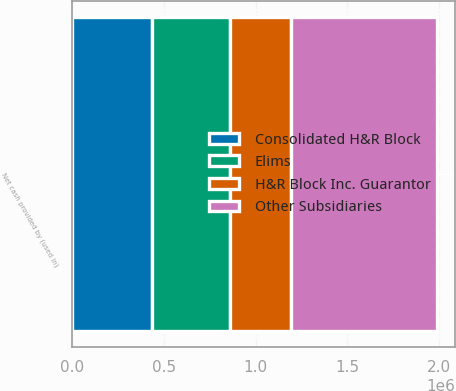Convert chart to OTSL. <chart><loc_0><loc_0><loc_500><loc_500><stacked_bar_chart><ecel><fcel>Net cash provided by (used in)<nl><fcel>Consolidated H&R Block<fcel>436843<nl><fcel>H&R Block Inc. Guarantor<fcel>332328<nl><fcel>Other Subsidiaries<fcel>798305<nl><fcel>Elims<fcel>421702<nl></chart> 